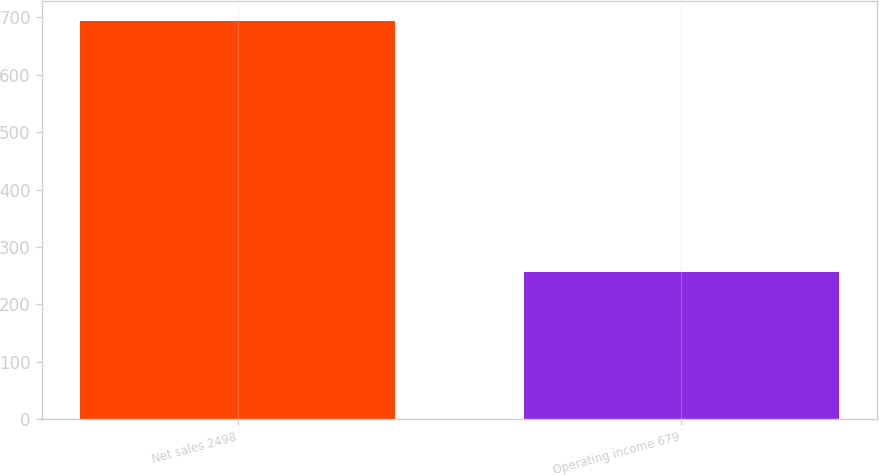Convert chart. <chart><loc_0><loc_0><loc_500><loc_500><bar_chart><fcel>Net sales 2498<fcel>Operating income 679<nl><fcel>694<fcel>257<nl></chart> 